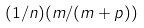<formula> <loc_0><loc_0><loc_500><loc_500>( 1 / n ) ( m / ( m + p ) )</formula> 